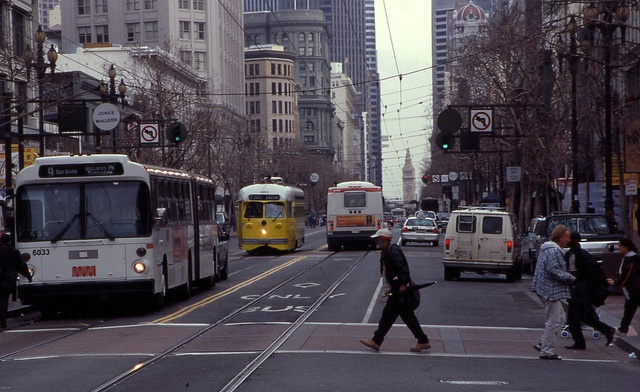Describe the objects in this image and their specific colors. I can see bus in black and gray tones, car in black and gray tones, train in black, olive, and gray tones, people in black and gray tones, and bus in black, gray, and maroon tones in this image. 